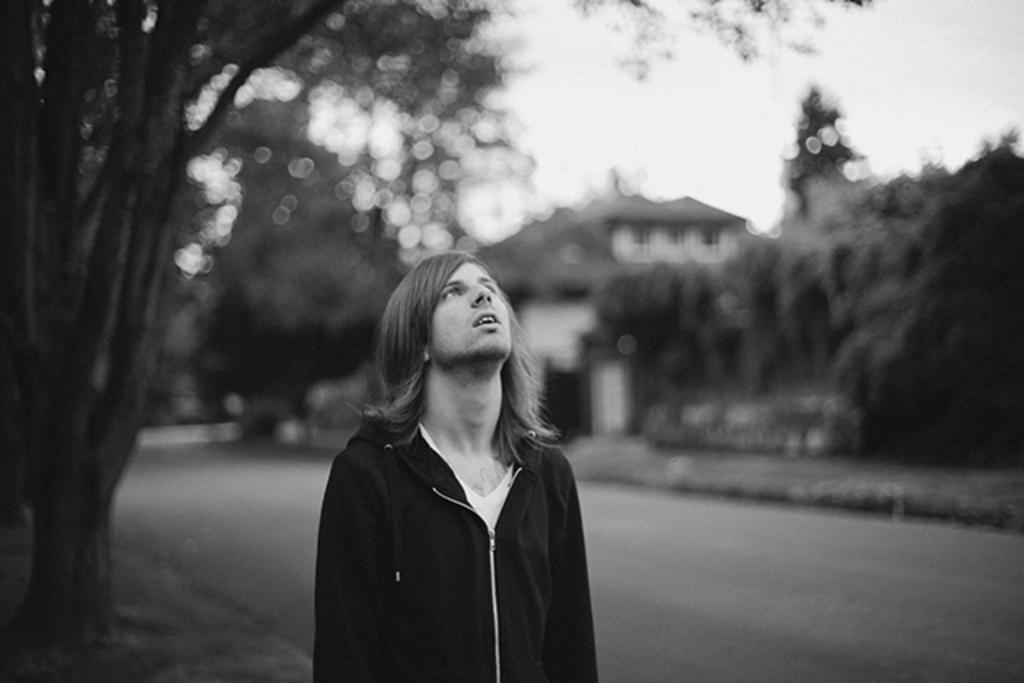What is the main subject in the middle of the picture? There is a person in the middle of the picture. What is located behind the person? There is a road behind the person. What can be seen in the background of the picture? There are trees, a house, and the sky visible in the background of the picture. What type of whip is the person holding in the image? There is no whip present in the image. What type of animal can be seen accompanying the person in the image? There is no animal present in the image. 